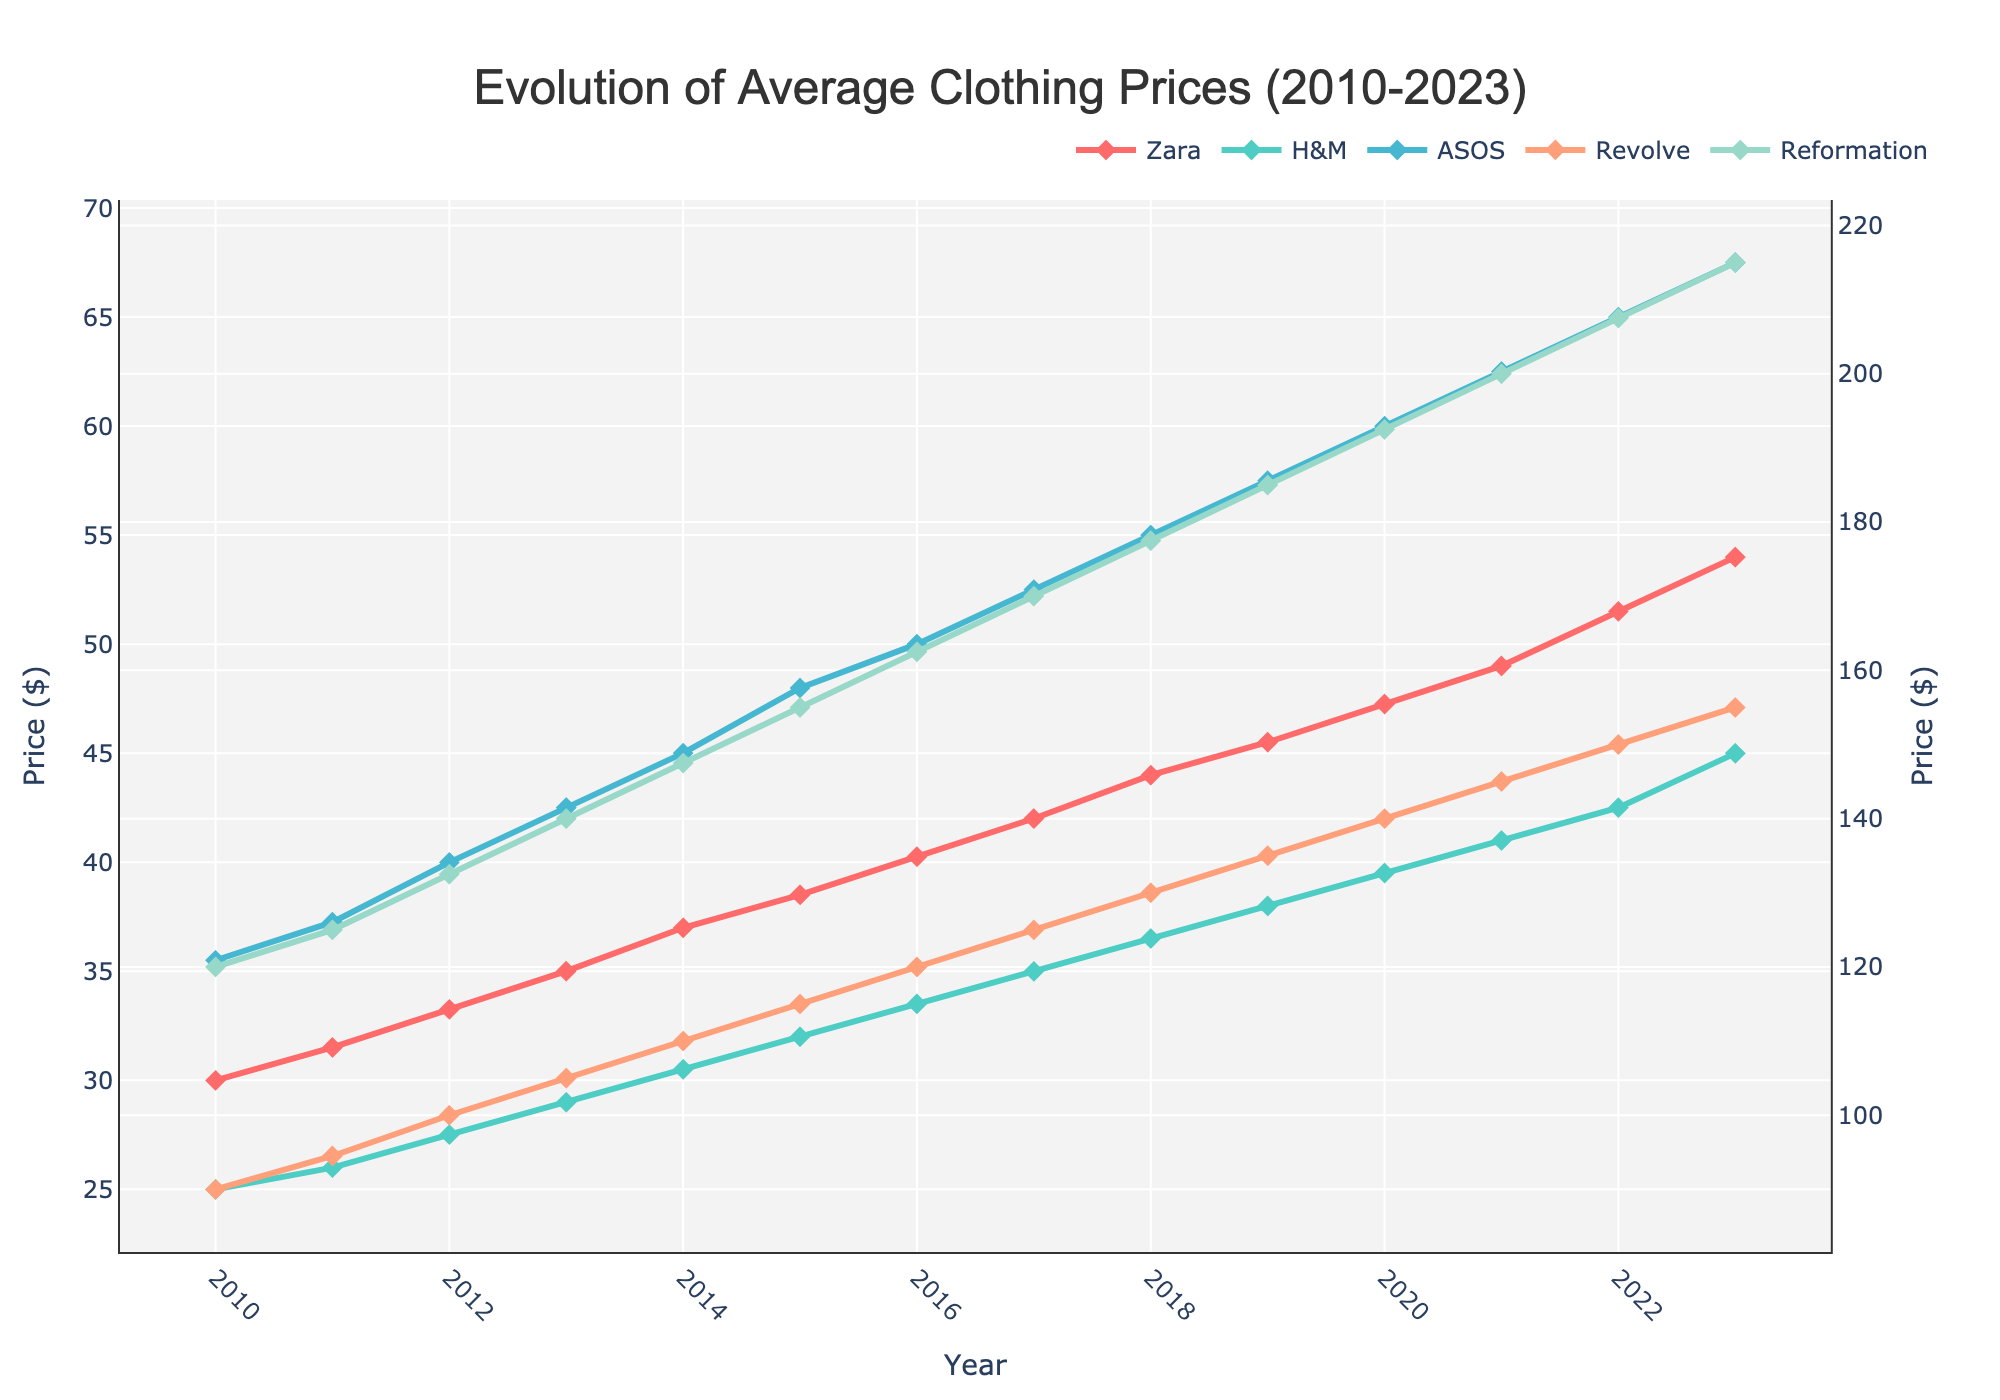What is the overall trend in the average clothing prices for Zara from 2010 to 2023? Over the period from 2010 to 2023, the average clothing prices for Zara show a consistent upward trend.
Answer: Upward trend Which brand had the highest average clothing price in 2023? In 2023, Reformation has the highest average clothing price as seen from the topmost line among all the brands on the plot.
Answer: Reformation Between which years did H&M have the steepest increase in average price? H&M's line shows the steepest increase in slope between 2022 and 2023. To identify this, examine the angle of the different segments of the line and find the steepest one.
Answer: 2022 to 2023 How do the average prices of Zara and ASOS compare in 2015? In 2015, the plot shows that Zara's average price is $38.50, whereas ASOS's average price is $47.99. Thus, ASOS's price is higher than Zara's.
Answer: ASOS is higher What's the average increase in price per year for Reformation from 2010 to 2023? Calculate the difference between Reformation's price in 2023 and 2010, which is $215.00 - $120.00 = $95.00. Then divide by the number of years (2023 - 2010 = 13) to find the average increase per year: $95.00 / 13 ≈ $7.31.
Answer: $7.31 Compare the price growth of Revolve and Reformation between 2010 and 2020. Revolve's price grew from $89.99 in 2010 to $140.00 in 2020, an increase of $50.01. Reformation's price grew from $120.00 to $192.50, an increase of $72.50. Therefore, Reformation had a larger growth in price.
Answer: Reformation is higher In which year do Zara and H&M have the smallest price difference? Examine the difference between Zara's and H&M's prices for each year. The plot shows the smallest difference in 2011 with Zara at $31.50 and H&M at $25.99, giving a difference of $5.51.
Answer: 2011 Which brand shows the most volatile price changes over the given period? Look for the brand with the most fluctuation or steep changes in the plot. Here, ASOS exhibits significant changes with steeper slopes compared to others, indicating the most volatility.
Answer: ASOS 